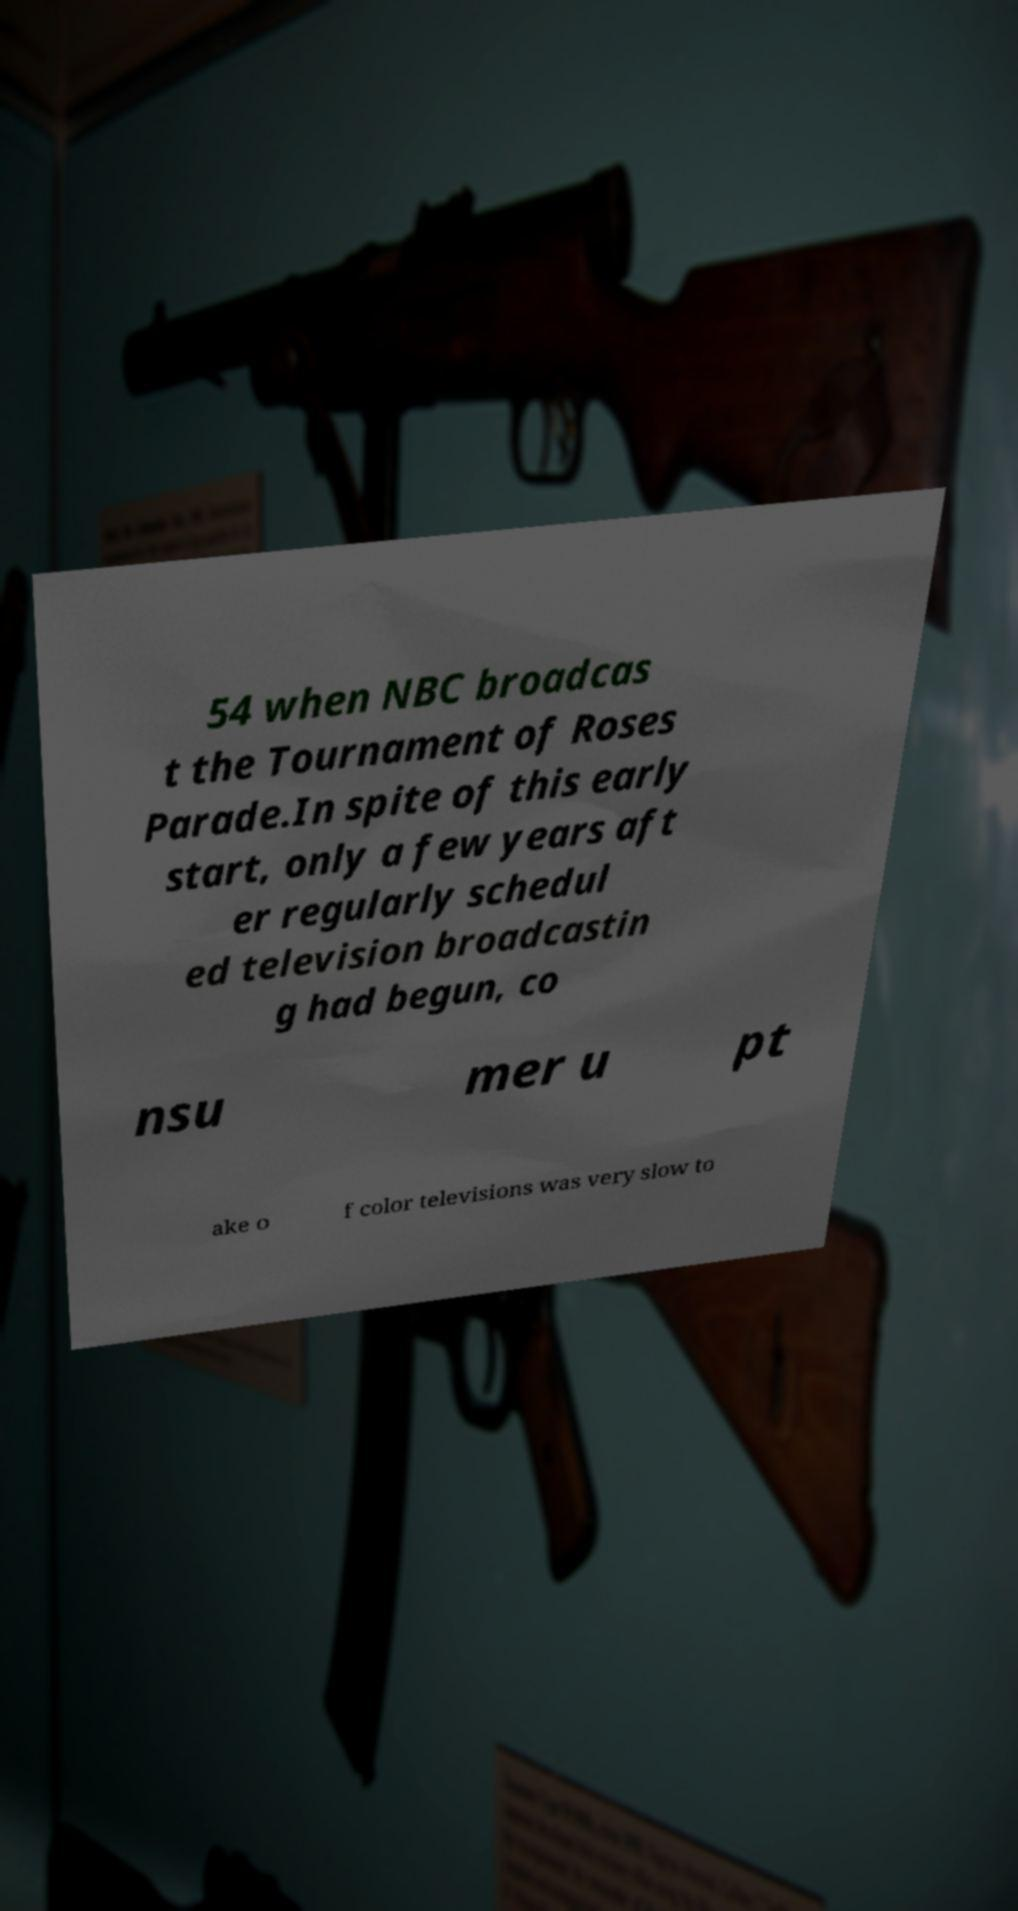Please read and relay the text visible in this image. What does it say? 54 when NBC broadcas t the Tournament of Roses Parade.In spite of this early start, only a few years aft er regularly schedul ed television broadcastin g had begun, co nsu mer u pt ake o f color televisions was very slow to 